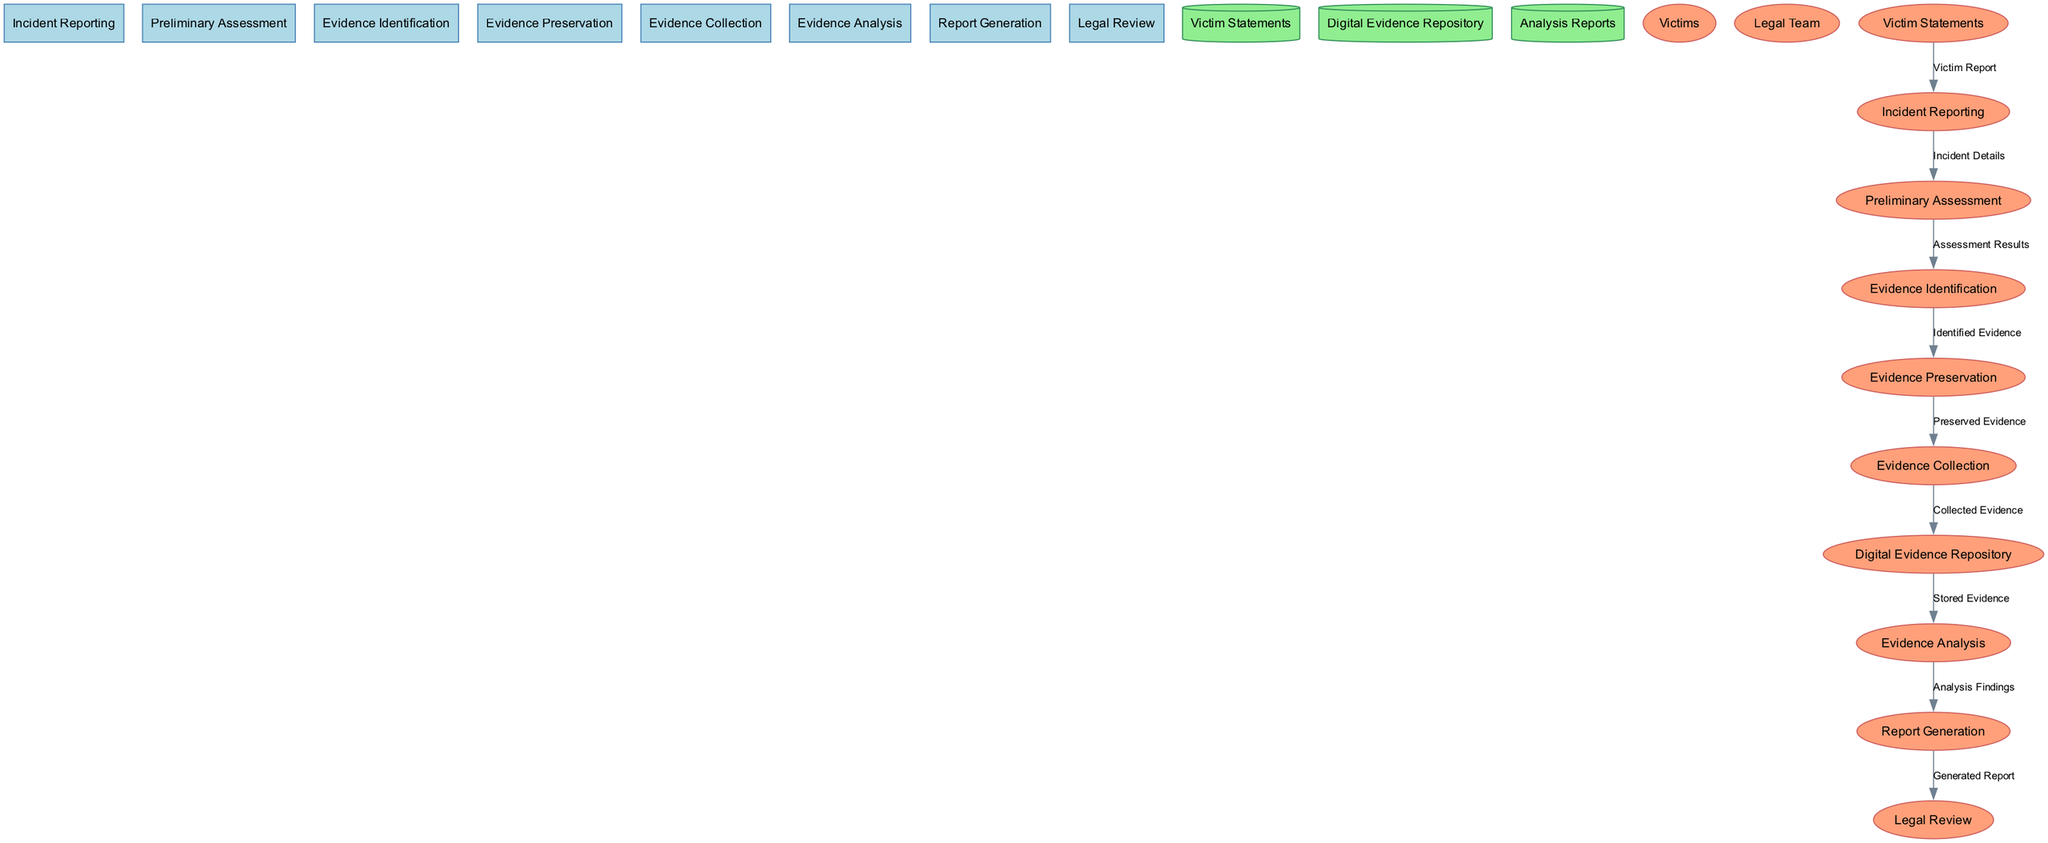What is the first process in the diagram? The first process listed is "Incident Reporting," which is shown at the top of the diagram.
Answer: Incident Reporting How many external entities are present in the diagram? The diagram shows two external entities: "Victims" and "Legal Team."
Answer: 2 Which process leads to "Evidence Collection"? "Evidence Preservation" is the process that leads to "Evidence Collection," as indicated by the data flow from the former to the latter.
Answer: Evidence Preservation What type of storage is used for "Digital Evidence Repository"? The "Digital Evidence Repository" is represented as a data store, which is typically depicted as a cylinder in a data flow diagram format.
Answer: Cylinder What is the data that flows from "Evidence Analysis" to "Report Generation"? The data flowing from "Evidence Analysis" to "Report Generation" is labeled as "Analysis Findings," which indicates the information being passed between these processes.
Answer: Analysis Findings What does the "Legal Review" process receive as input? The "Legal Review" process receives the "Generated Report" as its input, as shown by the data flow leading to it from "Report Generation."
Answer: Generated Report Which process does "Victim Statements" feed into? "Victim Statements" flows into "Incident Reporting," suggesting that victim statements are part of the information gathered at the incident reporting stage.
Answer: Incident Reporting How many data flows connect to the "Evidence Identification" process? There is one data flow connecting to "Evidence Identification," which comes from "Preliminary Assessment," showing the direct relationship between these two processes.
Answer: 1 What is the outcome of the "Report Generation"? The outcome of the "Report Generation" process is a "Generated Report," indicating the final product of this process.
Answer: Generated Report 